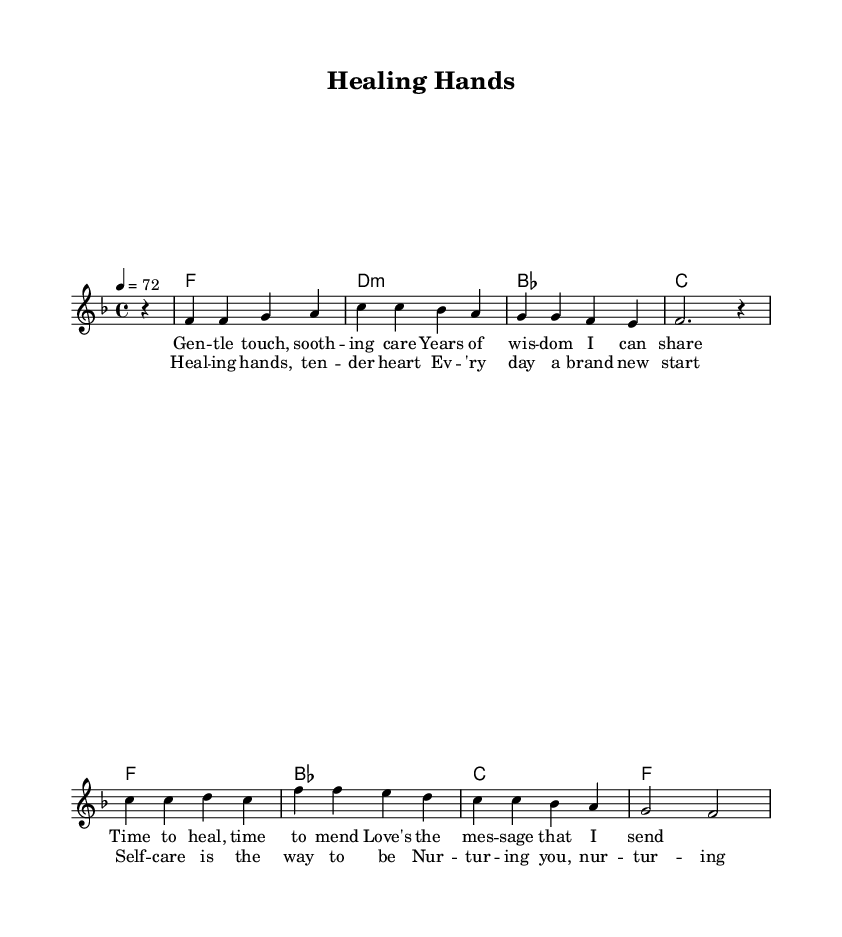What is the key signature of this music? The key signature is F major, which has one flat (B flat). This can be observed at the beginning of the music sheet where the key signature is indicated, and it corresponds to having a B flat in the scale.
Answer: F major What is the time signature of this music? The time signature is 4/4, which indicates that there are four beats in a measure and a quarter note gets one beat. This is shown at the beginning of the score, right next to the key signature.
Answer: 4/4 What is the tempo marking for this piece? The tempo marking is 72, which indicates the metronome setting for the piece, giving a moderate speed. This is written as "4 = 72" at the beginning of the music, signifying 72 beats per minute.
Answer: 72 What is the first note of the melody? The first note of the melody is F. This can be found at the very start of the melody line, where the note is placed on the staff as the first pitch.
Answer: F How many measures are there in the chorus? There are four measures in the chorus. By counting the grouping of the notes and lyrics in the chorus section, we can determine the number of distinct measures present.
Answer: 4 What is the main theme of the lyrics in this piece? The main theme of the lyrics is healing and self-care. The words emphasize nurturing and care, which connect to feelings of support and emotional recovery. This can be interpreted from both the verses and the chorus.
Answer: Healing and self-care What type of harmony is used in the music? The harmony used is mostly triadic, which features three-note chords. It can be observed in the chord progression written alongside the melody, displaying standard triads.
Answer: Triadic 